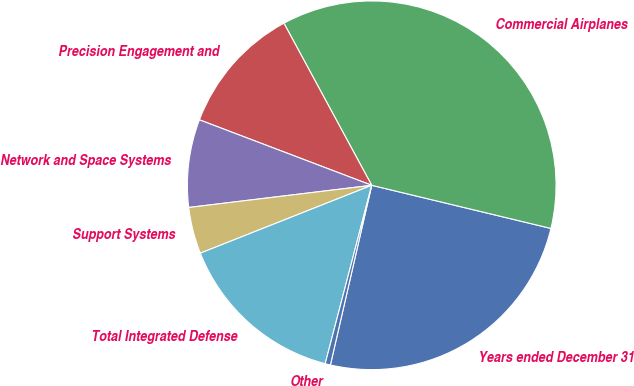Convert chart. <chart><loc_0><loc_0><loc_500><loc_500><pie_chart><fcel>Years ended December 31<fcel>Commercial Airplanes<fcel>Precision Engagement and<fcel>Network and Space Systems<fcel>Support Systems<fcel>Total Integrated Defense<fcel>Other<nl><fcel>24.84%<fcel>36.66%<fcel>11.32%<fcel>7.7%<fcel>4.08%<fcel>14.94%<fcel>0.46%<nl></chart> 